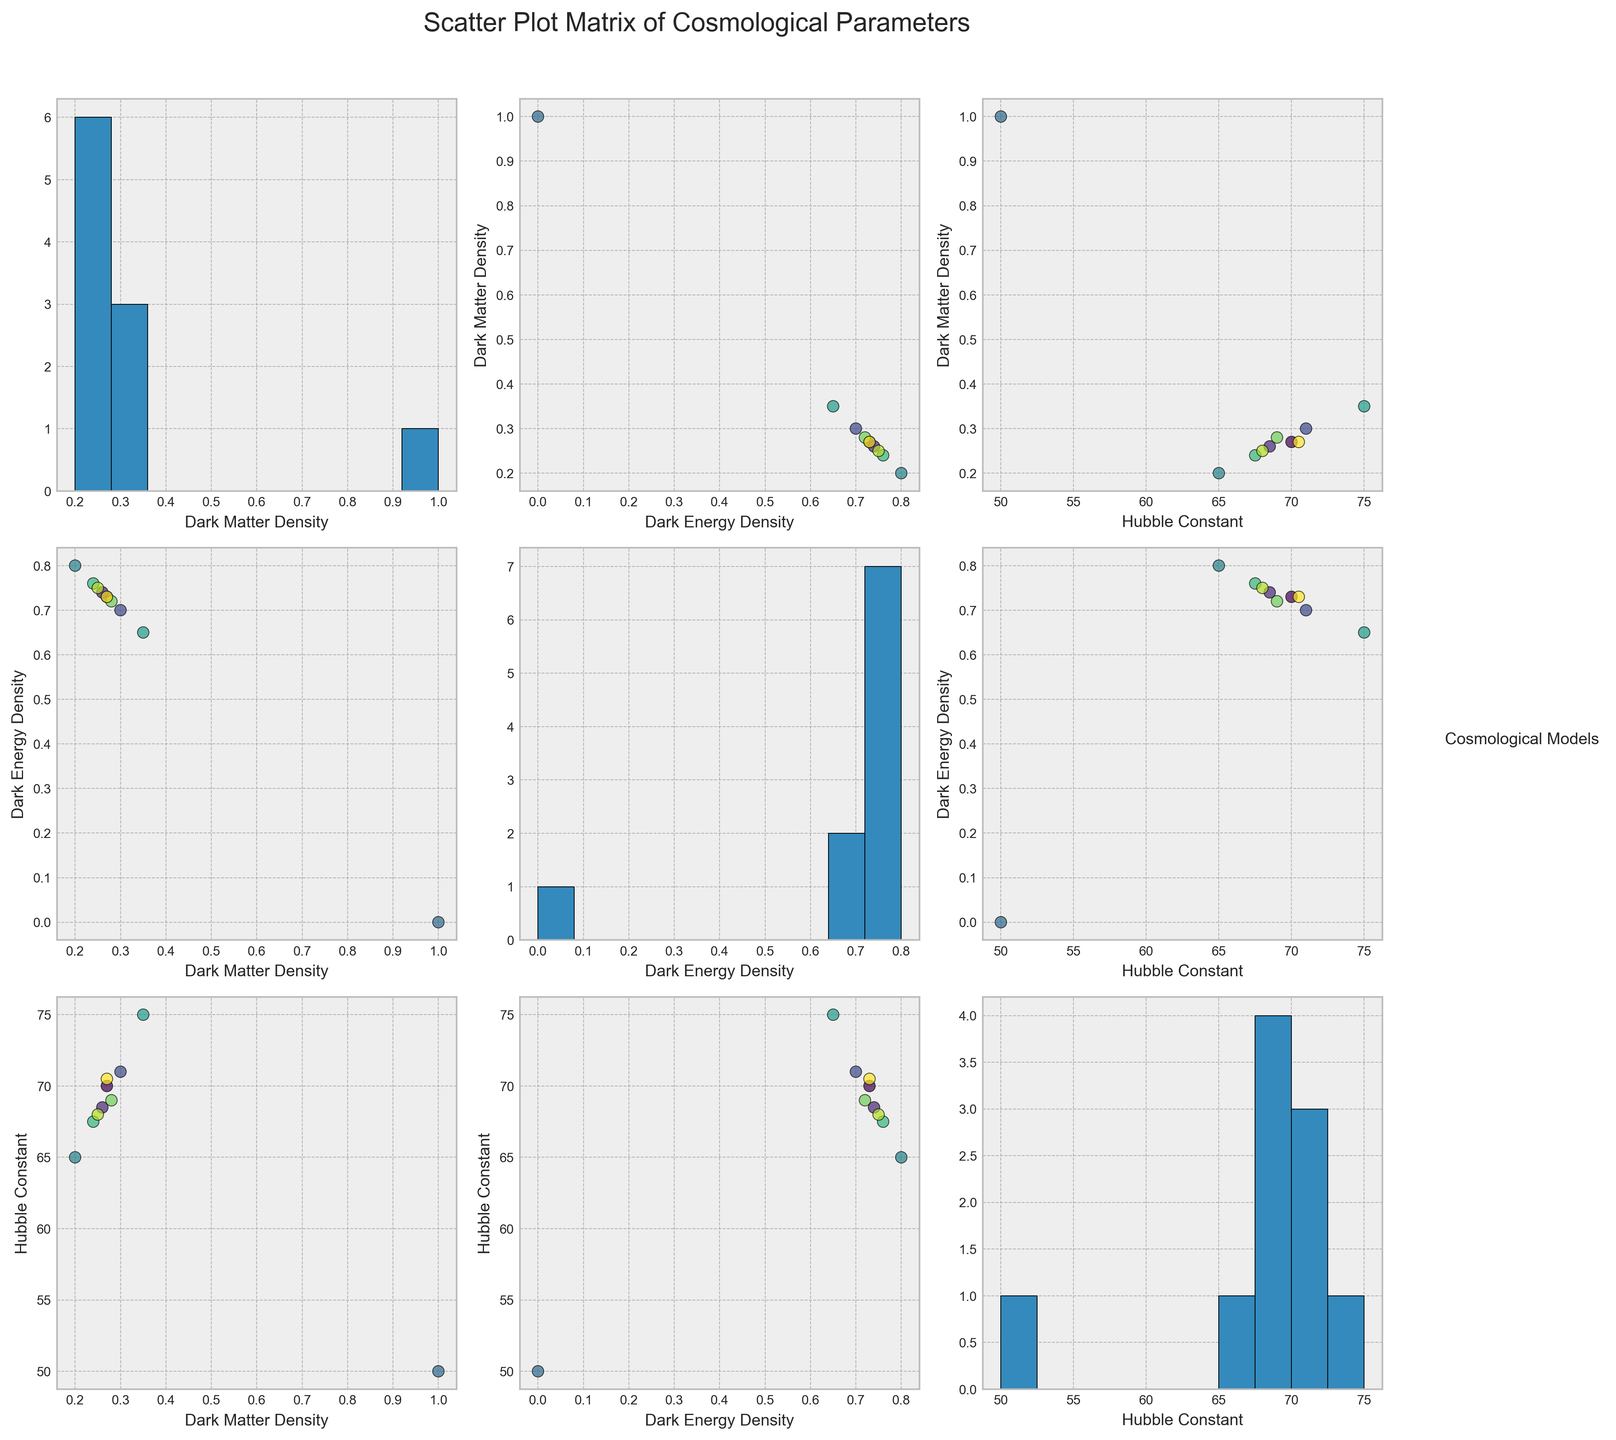What title is displayed on the scatter plot matrix? The title of the plot is typically placed at the top center of the figure. In this case, the title specified in the code is "Scatter Plot Matrix of Cosmological Parameters."
Answer: Scatter Plot Matrix of Cosmological Parameters How many distinct cosmological models are compared in the scatter plot matrix? The number of distinct cosmological models can be determined by counting the categories listed in the 'cosmological_model' column of the data. According to the data provided, there are 10 distinct cosmological models: Lambda_CDM, wCDM, Omega_m_omega_Lambda_flat, Einstein_de_Sitter, Open_CDM, Closed_CDM, Large_Number_Hypothesis, Quintessence_Model, K_Essence_Model, and XCDM_Model.
Answer: 10 Which cosmological model appears to have the highest Hubble constant on the scatter plots? By observing the scatter plots involving the "Hubble_constant" axis, the highest data point will distinguish the model with the highest Hubble constant. According to the data, the highest Hubble constant value is 75, corresponding to the 'Closed_CDM' model.
Answer: Closed_CDM In the subplot where dark matter density is plotted against dark energy density, how can you identify the model with a dark matter density of 1.0? To find the model with a dark matter density of 1.0, look at the x-axis labeled "dark_energy_density" and pinpoint where the y-coordinate (dark matter density) is 1.0. From the data, Einstein_de_Sitter has a dark matter density of 1.0, which should be evident in the scatter plots.
Answer: Einstein_de_Sitter What is the relationship between dark energy density and Hubble constant for the 'Open_CDM' model as seen in the plots? The 'Open_CDM' model has a dark energy density of 0.8 and a Hubble constant of 65. To observe this in the scatter plot where "dark_energy_density" is plotted against "Hubble_constant," look for the data point at (0.8, 65), which represents the 'Open_CDM' model.
Answer: Dark energy density of 0.8 and Hubble constant of 65 Can you find any models that have both dark energy density and Hubble constant values higher than the Quintessence_Model? According to the data, the Quintessence_Model has a dark energy density of 0.72 and a Hubble constant of 69. Checking values higher than these in the scatter plots shows that 'Closed_CDM' has higher values for both: dark energy density (0.65 < 0.72) and Hubble constant (75 > 69).
Answer: Closed_CDM What is the general trend observed between dark matter density and Hubble constant across various cosmological models? Observing the scatter plot with "dark_matter_density" on the y-axis and "Hubble_constant" on the x-axis, it can be noted that as dark matter density increases, the Hubble constant also generally increases. However, the 'Einstein_de_Sitter' model is an outlier with exceptionally high dark matter density and low Hubble constant.
Answer: Positive correlation with an outlier Which histogram shows the distribution of Hubble constant values across the models? In a scatter plot matrix, each diagonal element usually contains histograms of individual variables. The histogram diagonal plot labeled "Hubble_constant" shows the distribution of Hubble constant values.
Answer: Diagonal labeled "Hubble_constant" 